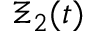Convert formula to latex. <formula><loc_0><loc_0><loc_500><loc_500>\Xi _ { 2 } ( t )</formula> 